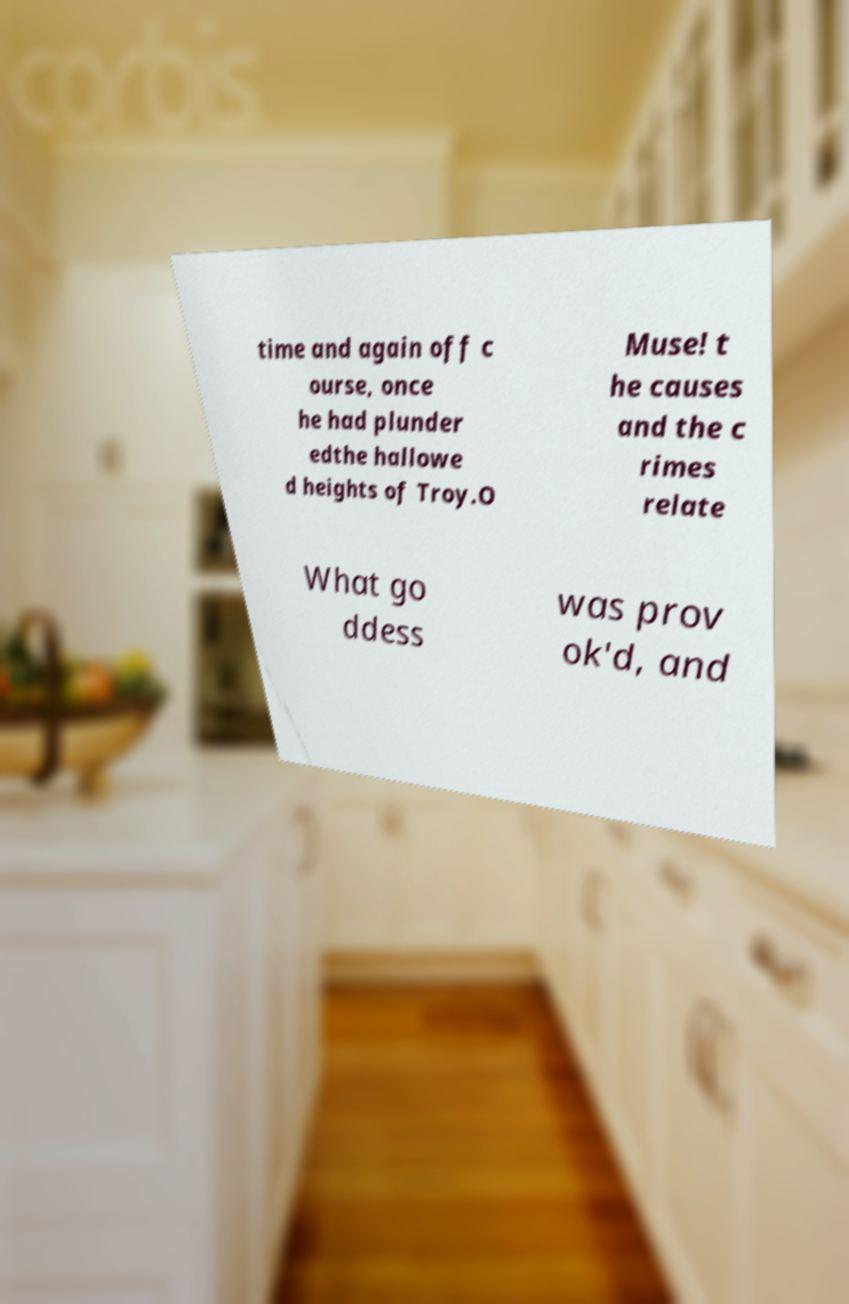Please identify and transcribe the text found in this image. time and again off c ourse, once he had plunder edthe hallowe d heights of Troy.O Muse! t he causes and the c rimes relate What go ddess was prov ok'd, and 